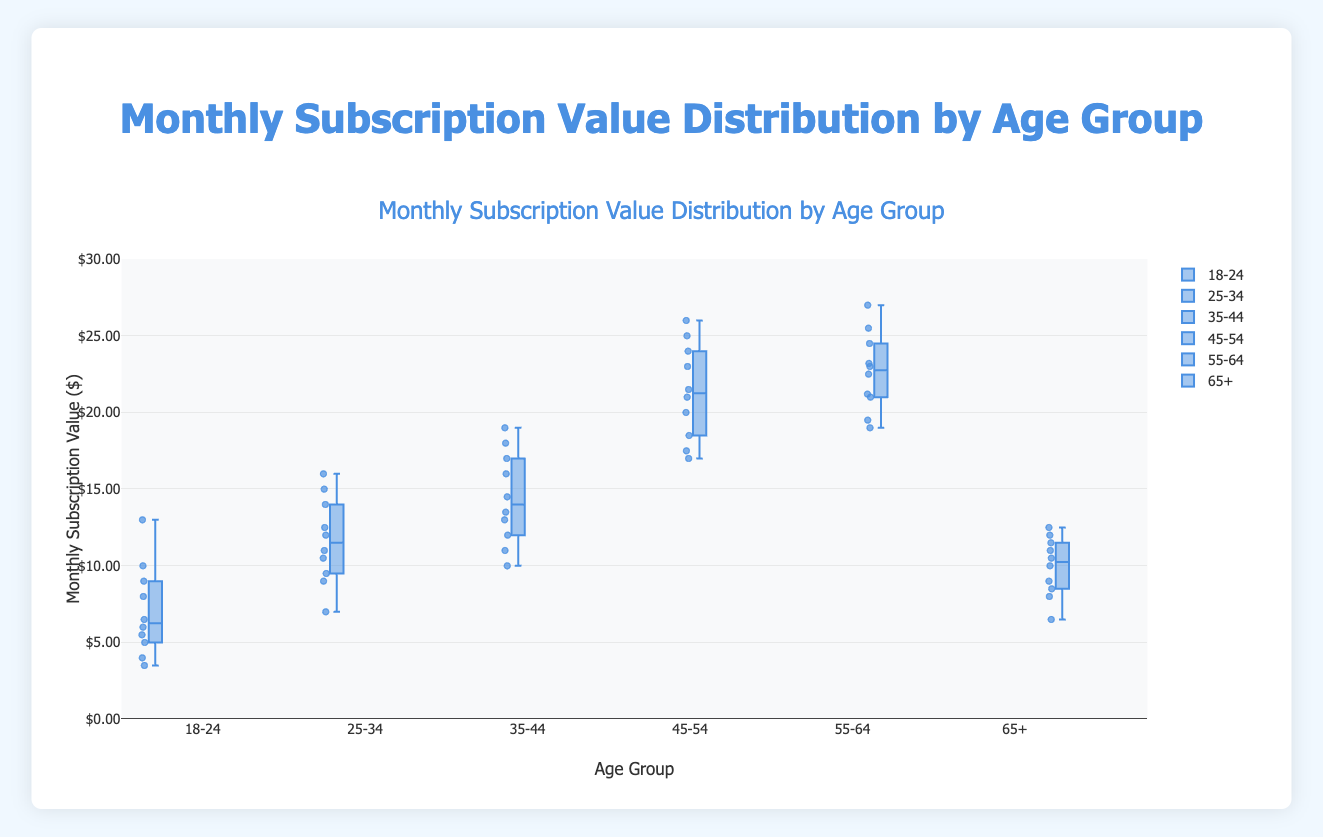What's the title of the plot? The title of the plot is typically displayed prominently at the top of the figure. In this case, it reads 'Monthly Subscription Value Distribution by Age Group'
Answer: Monthly Subscription Value Distribution by Age Group How many age groups are represented in the plot? The x-axis displays the different age groups, and by counting the labels, we can see there are six age groups: '18-24', '25-34', '35-44', '45-54', '55-64', and '65+'
Answer: 6 Which age group has the highest median monthly subscription value? The median value for each age group can be identified by the line within the box of each box plot. The '55-64' age group has the highest line through the box compared to the others.
Answer: 55-64 Compare the range of monthly subscription values for the '18-24' and '45-54' age groups. Which one has a larger range? To compare the range, look at the length of the boxes and the whiskers. The '45-54' age group has a larger range as its box and whiskers span from around $16.99 to $25.99, while '18-24' ranges from about $3.49 to $12.99.
Answer: 45-54 What is the interquartile range (IQR) for the '35-44' age group? The IQR is the difference between the third quartile (the top of the box) and the first quartile (the bottom of the box). For '35-44', it ranges approximately from $11.99 to $15.99. Therefore, IQR is 15.99 - 11.99.
Answer: $4.00 Which age group exhibits the least variability in their monthly subscription values? Variability in a box plot can be indicated by the range (length of the box and whiskers). The '65+' age group shows the least variability as it has the smallest box and whiskers span.
Answer: 65+ How do the median subscription values compare between '25-34' and '55-64' age groups? The median subscription values are represented by the central line in the boxes. The '55-64' age group has a higher median value compared to the '25-34' age group.
Answer: 55-64 > 25-34 How many outliers are there in the '18-24' age group? Outliers in a box plot are individual points outside the whiskers. Identify these points visually. There are two apparent outliers in the '18-24' age group (near $3.49)
Answer: 2 What's the approximate range of monthly subscription values for the '25-34' age group? The range is indicated by the lowest and highest whiskers, which span from approximately $6.99 to $15.99 for the '25-34' age group.
Answer: $6.99 - $15.99 What’s the highest individual monthly subscription value in the plot and which age group does it belong to? The highest value in the plot is indicated by the topmost point among all box plots. For the '55-64' age group, this value is around $26.99.
Answer: $26.99, 55-64 